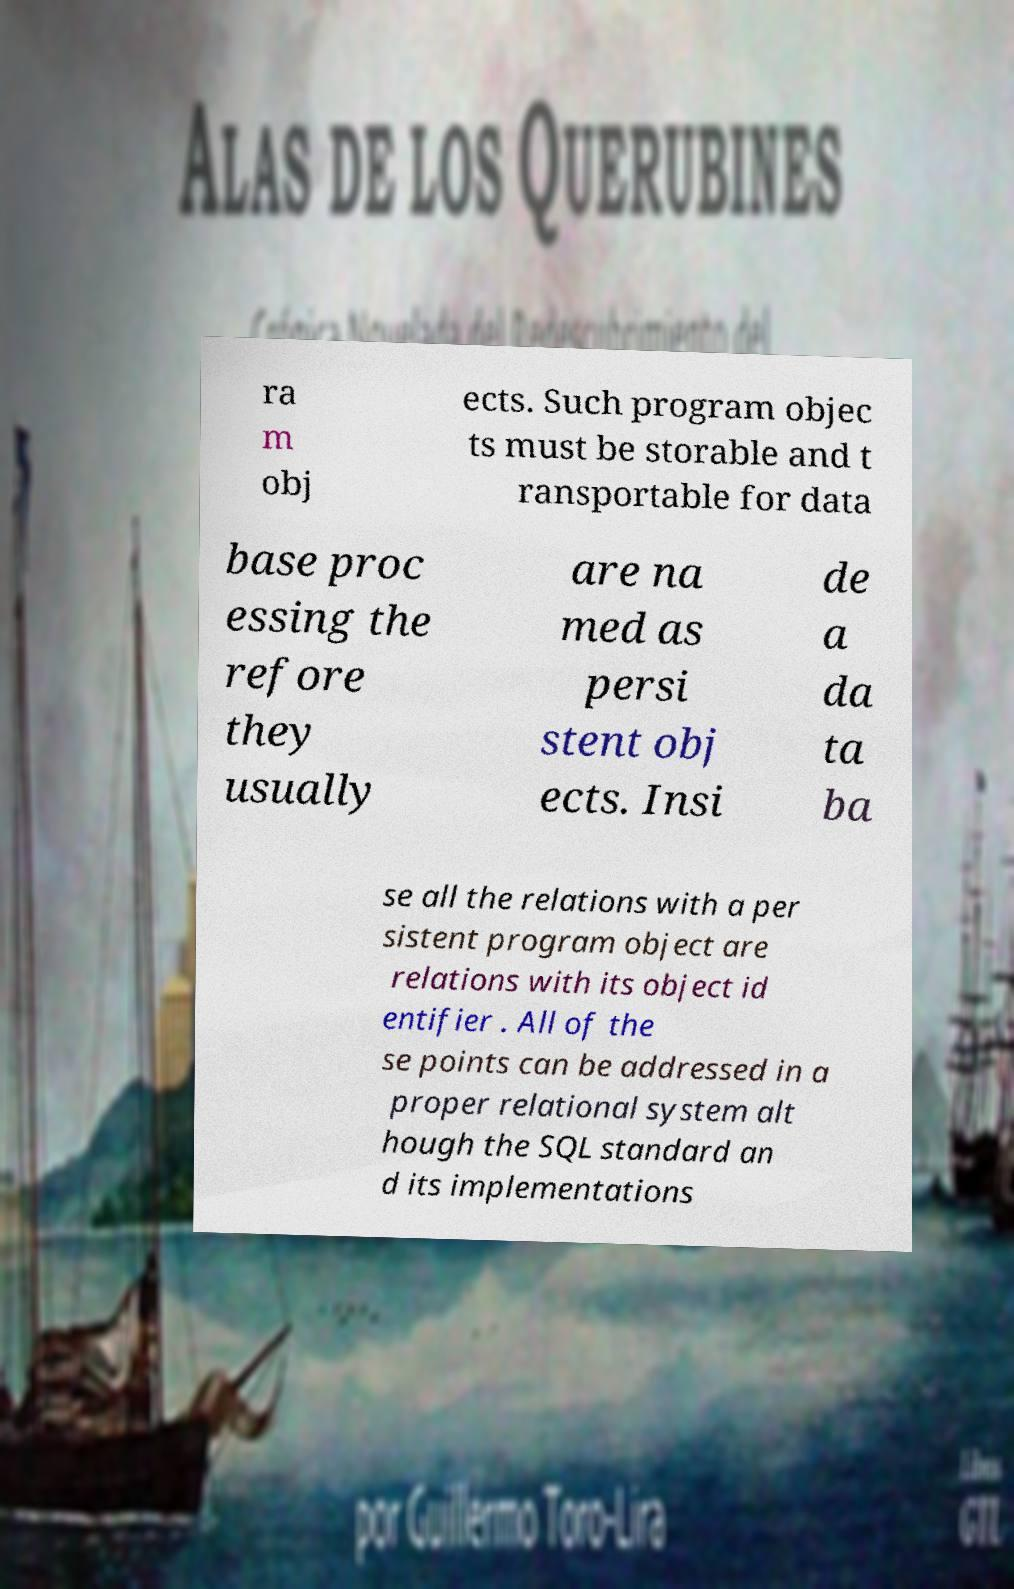There's text embedded in this image that I need extracted. Can you transcribe it verbatim? ra m obj ects. Such program objec ts must be storable and t ransportable for data base proc essing the refore they usually are na med as persi stent obj ects. Insi de a da ta ba se all the relations with a per sistent program object are relations with its object id entifier . All of the se points can be addressed in a proper relational system alt hough the SQL standard an d its implementations 